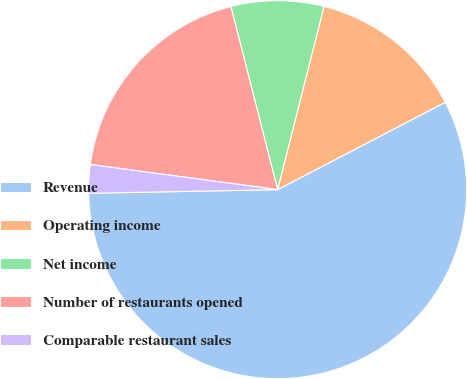Convert chart. <chart><loc_0><loc_0><loc_500><loc_500><pie_chart><fcel>Revenue<fcel>Operating income<fcel>Net income<fcel>Number of restaurants opened<fcel>Comparable restaurant sales<nl><fcel>57.35%<fcel>13.41%<fcel>7.92%<fcel>18.9%<fcel>2.43%<nl></chart> 